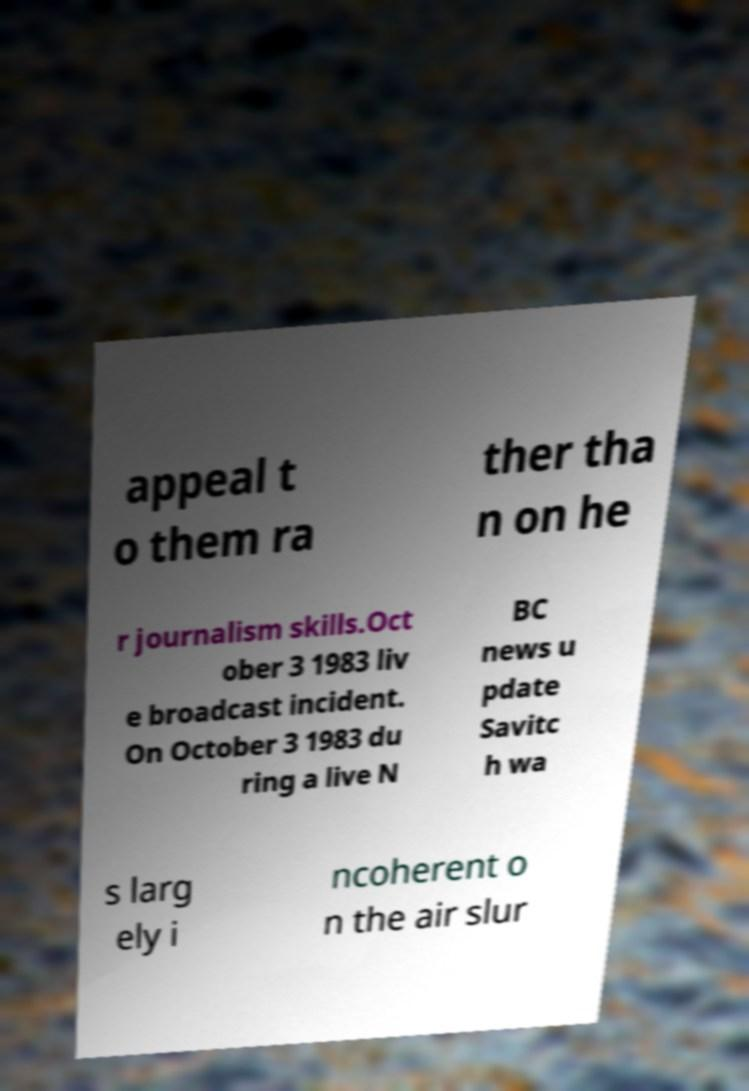Please read and relay the text visible in this image. What does it say? appeal t o them ra ther tha n on he r journalism skills.Oct ober 3 1983 liv e broadcast incident. On October 3 1983 du ring a live N BC news u pdate Savitc h wa s larg ely i ncoherent o n the air slur 